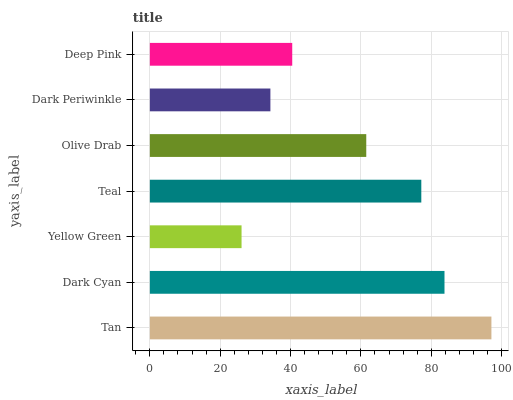Is Yellow Green the minimum?
Answer yes or no. Yes. Is Tan the maximum?
Answer yes or no. Yes. Is Dark Cyan the minimum?
Answer yes or no. No. Is Dark Cyan the maximum?
Answer yes or no. No. Is Tan greater than Dark Cyan?
Answer yes or no. Yes. Is Dark Cyan less than Tan?
Answer yes or no. Yes. Is Dark Cyan greater than Tan?
Answer yes or no. No. Is Tan less than Dark Cyan?
Answer yes or no. No. Is Olive Drab the high median?
Answer yes or no. Yes. Is Olive Drab the low median?
Answer yes or no. Yes. Is Dark Cyan the high median?
Answer yes or no. No. Is Tan the low median?
Answer yes or no. No. 